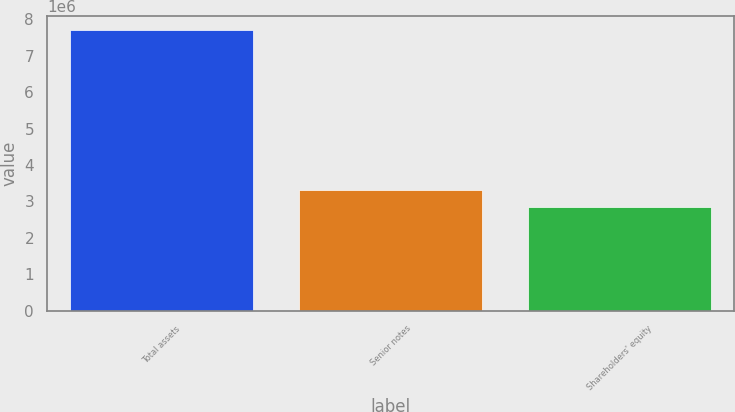Convert chart. <chart><loc_0><loc_0><loc_500><loc_500><bar_chart><fcel>Total assets<fcel>Senior notes<fcel>Shareholders' equity<nl><fcel>7.70846e+06<fcel>3.32297e+06<fcel>2.8357e+06<nl></chart> 